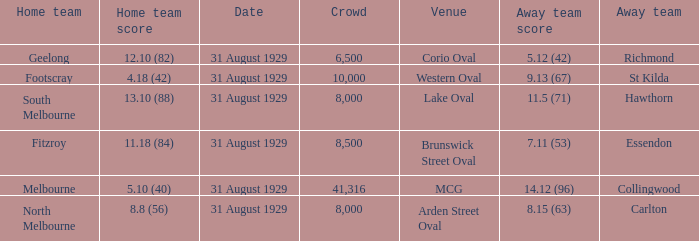What date was the game when the away team was carlton? 31 August 1929. 